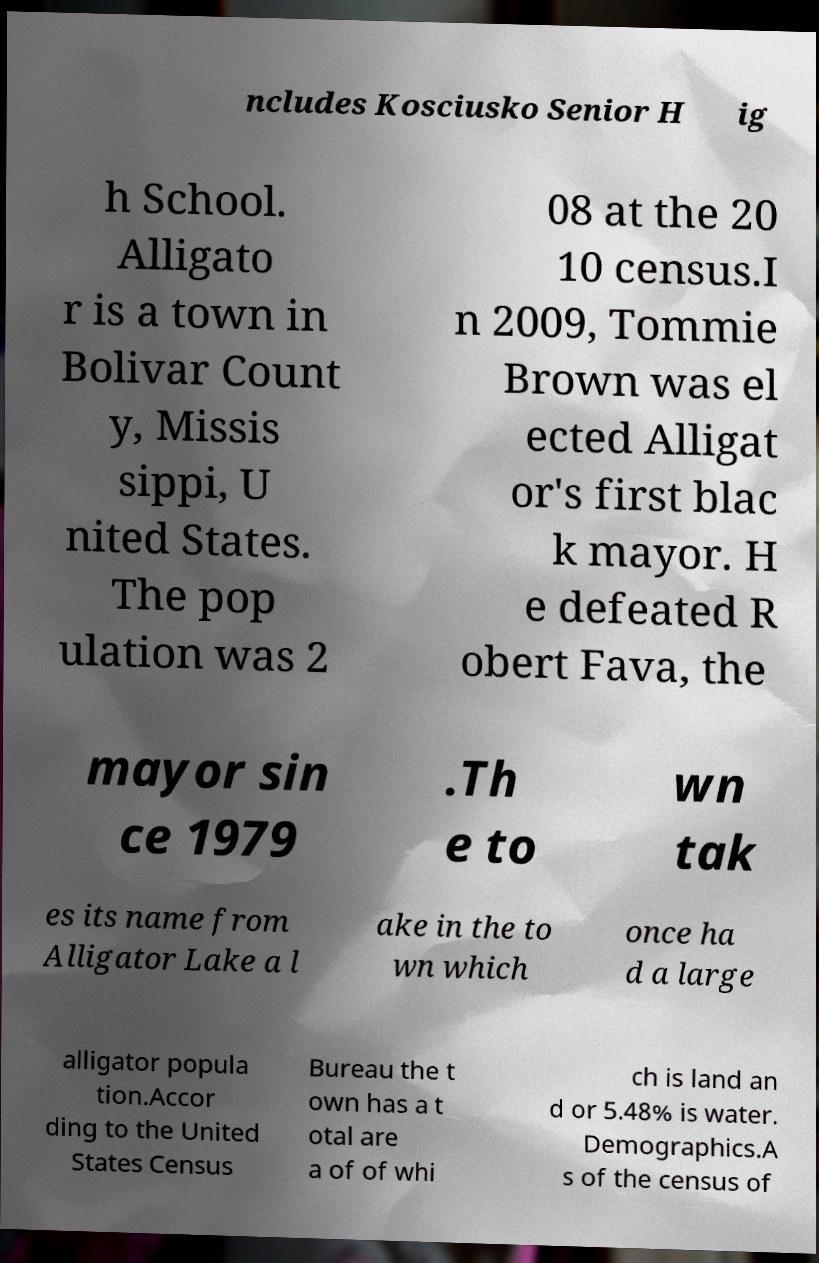I need the written content from this picture converted into text. Can you do that? ncludes Kosciusko Senior H ig h School. Alligato r is a town in Bolivar Count y, Missis sippi, U nited States. The pop ulation was 2 08 at the 20 10 census.I n 2009, Tommie Brown was el ected Alligat or's first blac k mayor. H e defeated R obert Fava, the mayor sin ce 1979 .Th e to wn tak es its name from Alligator Lake a l ake in the to wn which once ha d a large alligator popula tion.Accor ding to the United States Census Bureau the t own has a t otal are a of of whi ch is land an d or 5.48% is water. Demographics.A s of the census of 